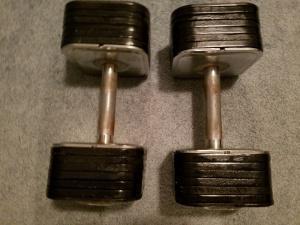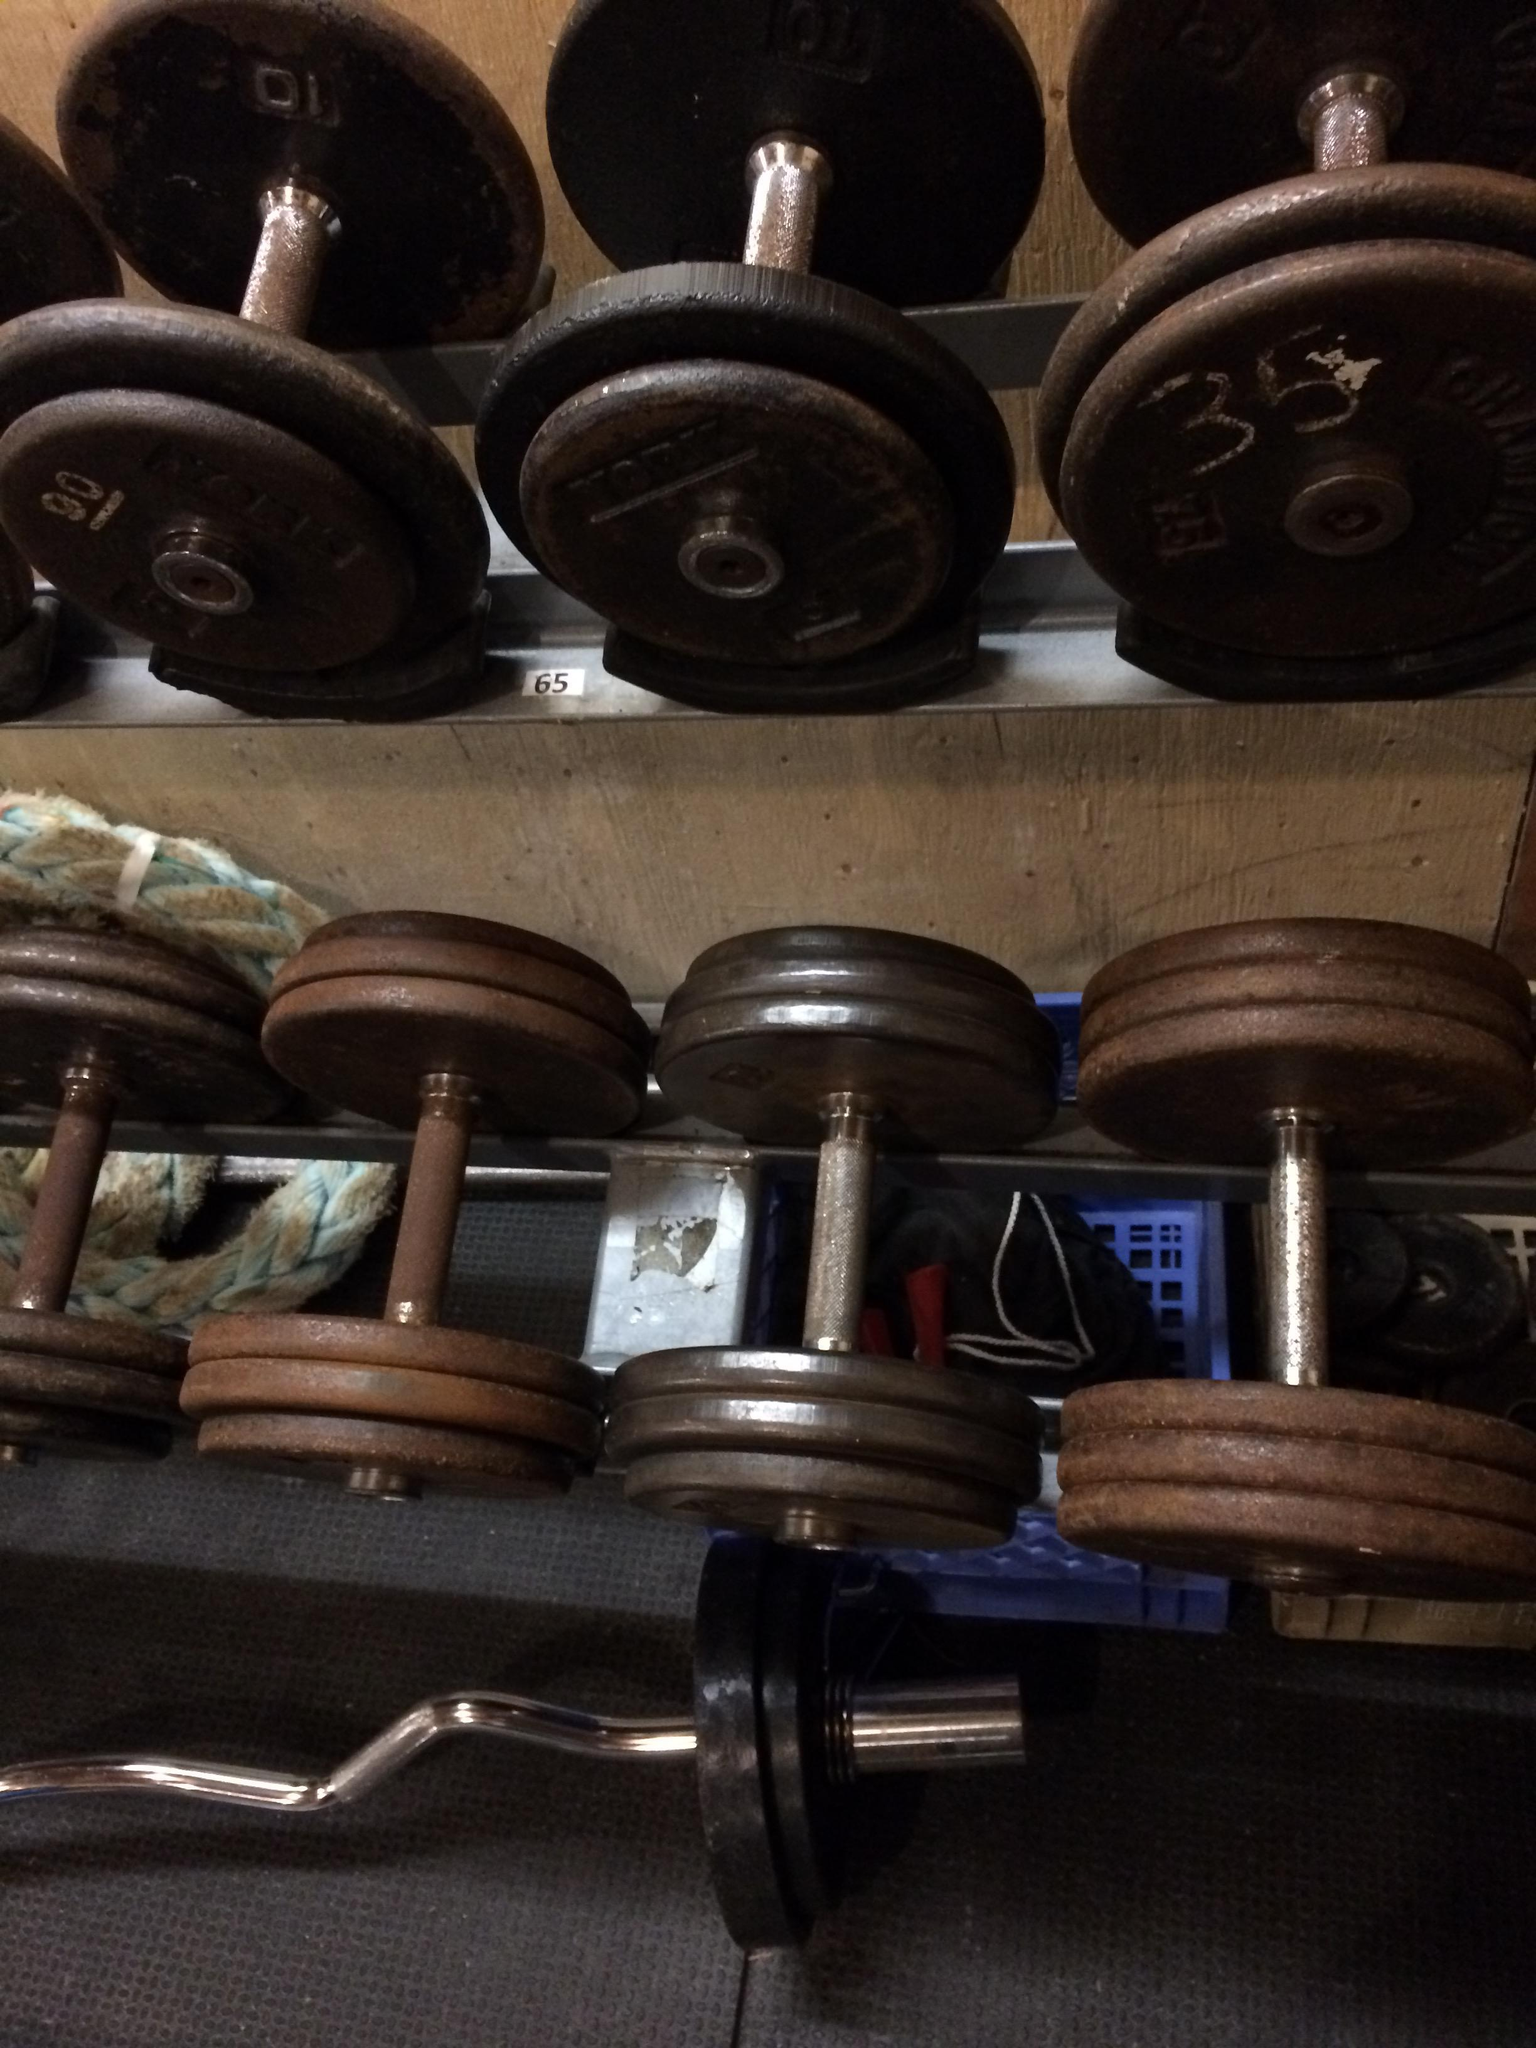The first image is the image on the left, the second image is the image on the right. Analyze the images presented: Is the assertion "One image shows exactly two dumbbells, and the other image shows a row of at least six dumbbells with faceted hexagon shaped ends." valid? Answer yes or no. No. 